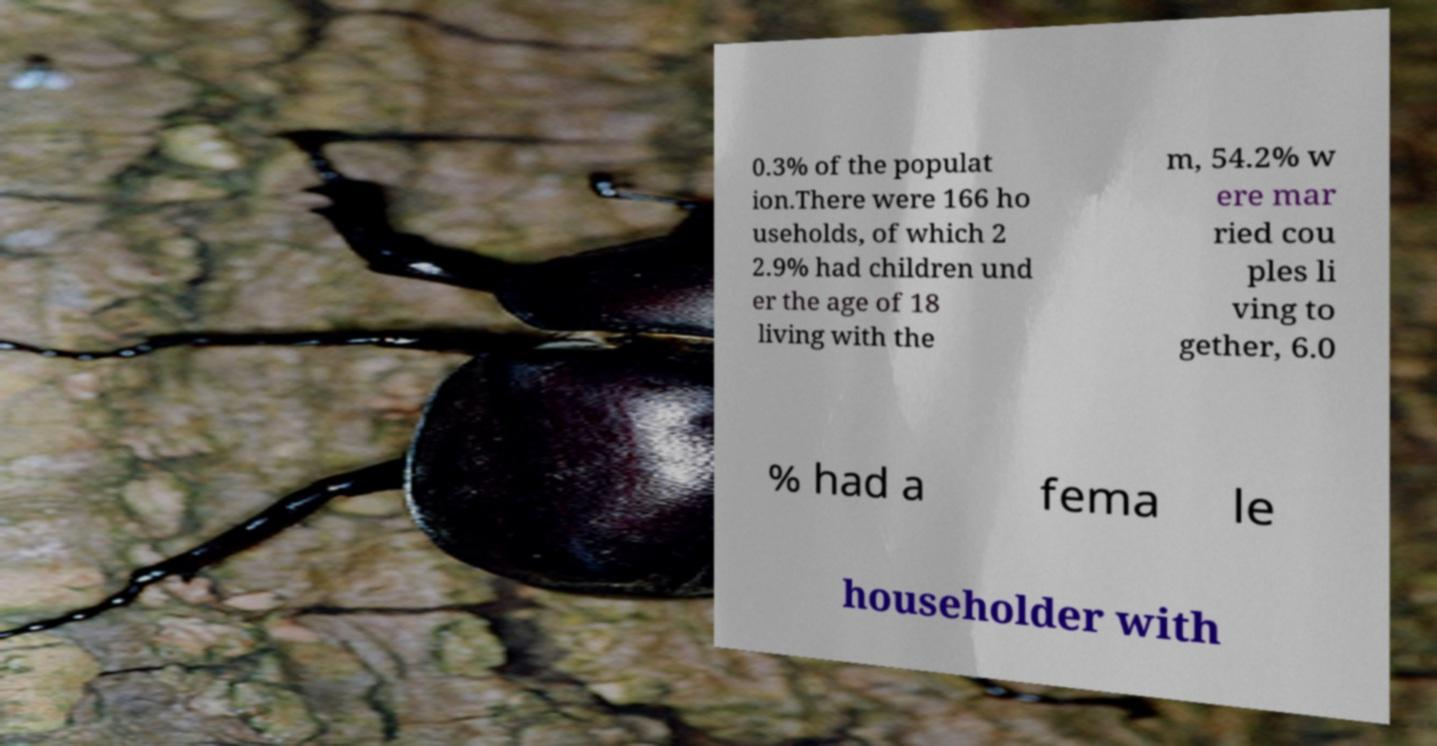There's text embedded in this image that I need extracted. Can you transcribe it verbatim? 0.3% of the populat ion.There were 166 ho useholds, of which 2 2.9% had children und er the age of 18 living with the m, 54.2% w ere mar ried cou ples li ving to gether, 6.0 % had a fema le householder with 